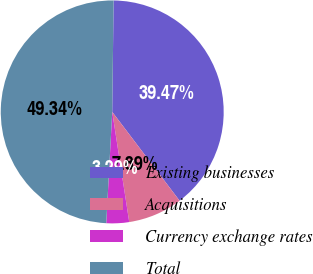Convert chart to OTSL. <chart><loc_0><loc_0><loc_500><loc_500><pie_chart><fcel>Existing businesses<fcel>Acquisitions<fcel>Currency exchange rates<fcel>Total<nl><fcel>39.47%<fcel>7.89%<fcel>3.29%<fcel>49.34%<nl></chart> 